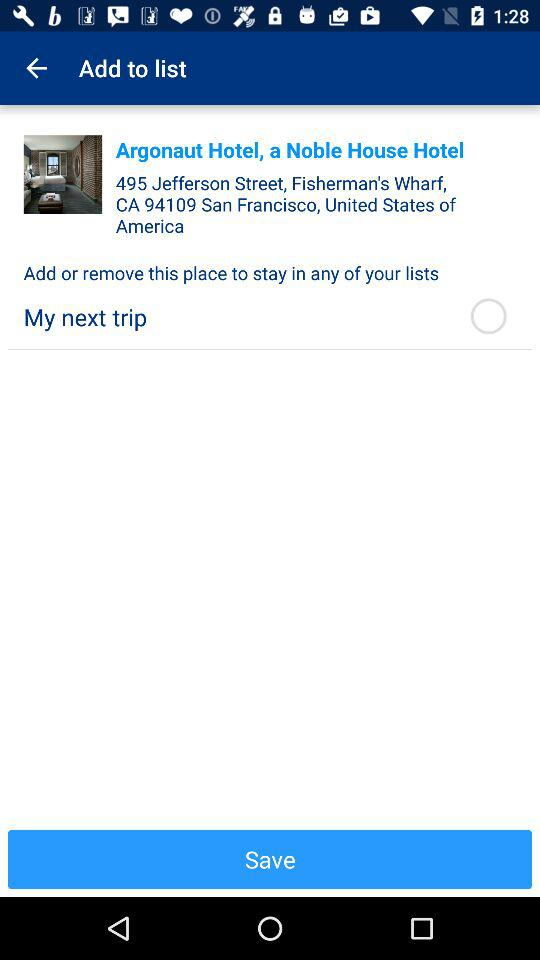What is the status of "My next trip"? The status is "off". 